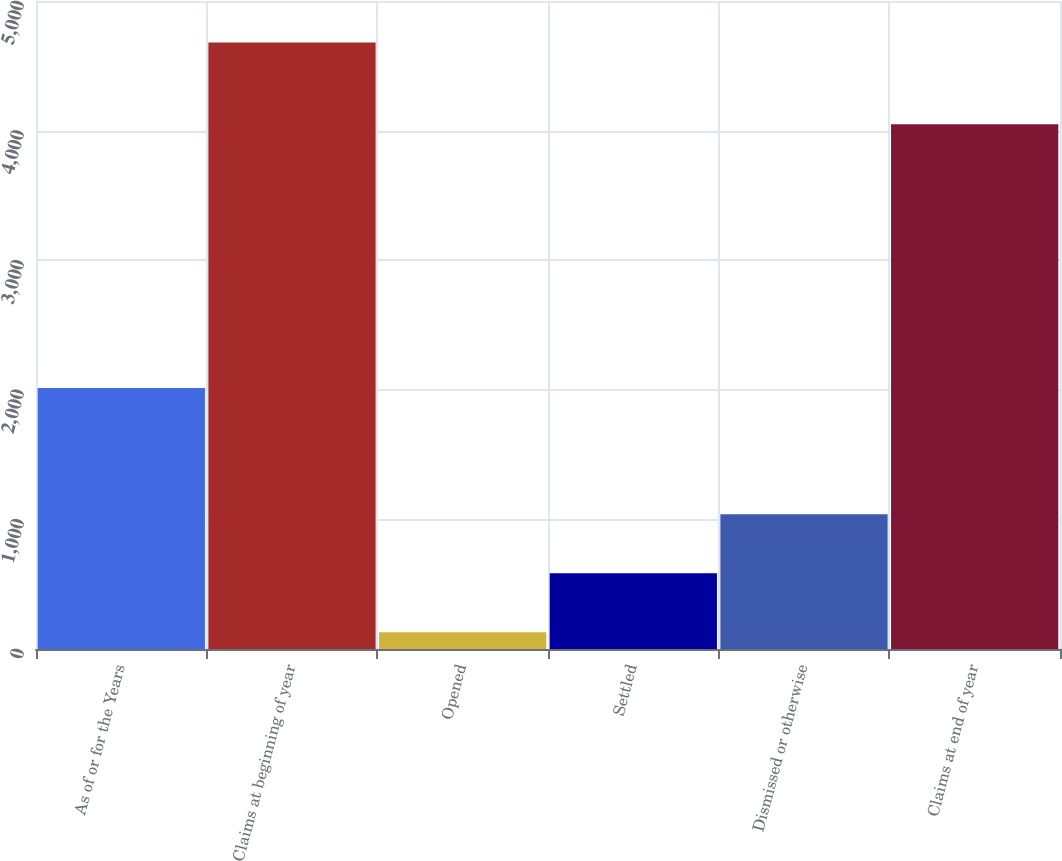<chart> <loc_0><loc_0><loc_500><loc_500><bar_chart><fcel>As of or for the Years<fcel>Claims at beginning of year<fcel>Opened<fcel>Settled<fcel>Dismissed or otherwise<fcel>Claims at end of year<nl><fcel>2014<fcel>4680<fcel>130<fcel>585<fcel>1040<fcel>4049<nl></chart> 